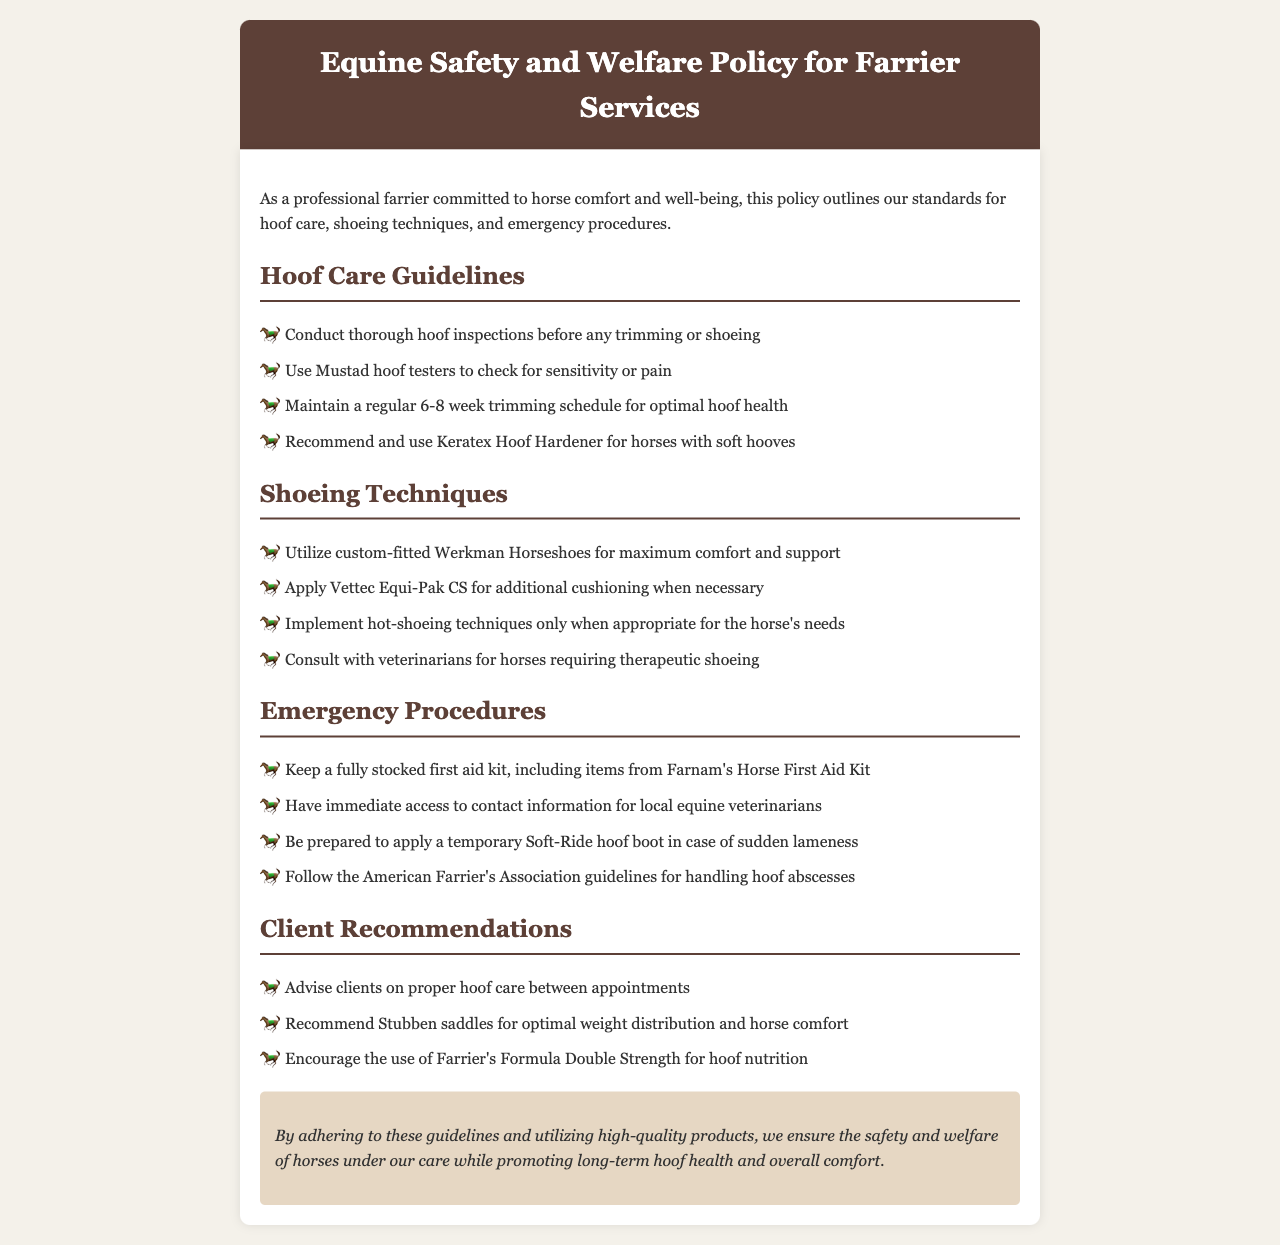What is the recommended trimming schedule? The document states that a regular 6-8 week trimming schedule should be maintained for optimal hoof health.
Answer: 6-8 weeks What product is recommended for soft hooves? According to the guidelines, Keratex Hoof Hardener is recommended for horses with soft hooves.
Answer: Keratex Hoof Hardener What type of horseshoes are utilized for comfort? The document mentions the use of custom-fitted Werkman Horseshoes for maximum comfort and support.
Answer: Werkman Horseshoes Which emergency item is mentioned for sudden lameness? The policy indicates the necessity of having a temporary Soft-Ride hoof boot ready for sudden lameness.
Answer: Soft-Ride hoof boot How often should clients be advised on hoof care? The document advises clients on proper hoof care between appointments without specifying a frequency.
Answer: Between appointments What is the main purpose of this policy document? The policy outlines standards for hoof care, shoeing techniques, and emergency procedures to ensure horse comfort and welfare.
Answer: Horse comfort and welfare Which first aid kit is specifically mentioned? The document specifies using Farnam's Horse First Aid Kit as part of the emergency procedures.
Answer: Farnam's Horse First Aid Kit What is the purpose of Vettec Equi-Pak CS? The document states that Vettec Equi-Pak CS is applied for additional cushioning when necessary.
Answer: Additional cushioning 